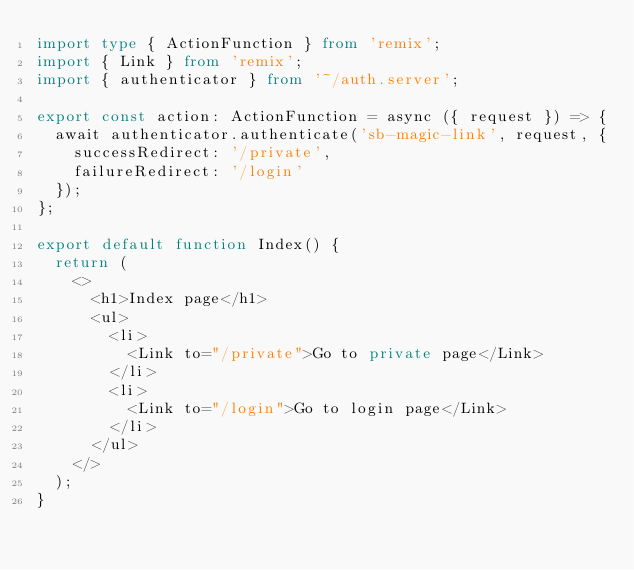Convert code to text. <code><loc_0><loc_0><loc_500><loc_500><_TypeScript_>import type { ActionFunction } from 'remix';
import { Link } from 'remix';
import { authenticator } from '~/auth.server';

export const action: ActionFunction = async ({ request }) => {
  await authenticator.authenticate('sb-magic-link', request, {
    successRedirect: '/private',
    failureRedirect: '/login'
  });
};

export default function Index() {
  return (
    <>
      <h1>Index page</h1>
      <ul>
        <li>
          <Link to="/private">Go to private page</Link>
        </li>
        <li>
          <Link to="/login">Go to login page</Link>
        </li>
      </ul>
    </>
  );
}
</code> 